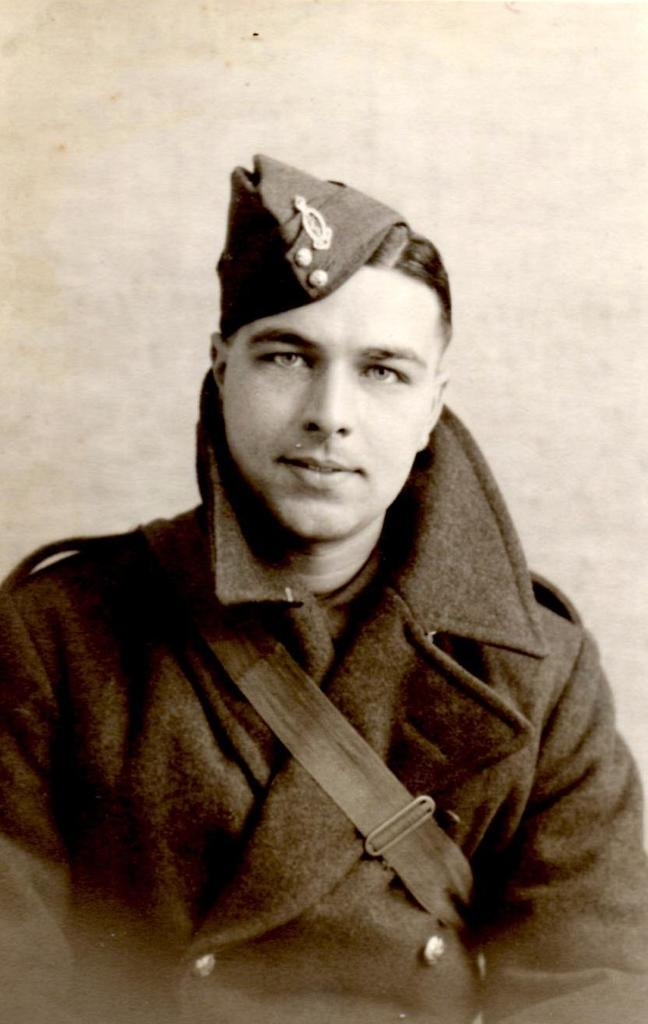What is the main subject of the image? The main subject of the image is a person. What can be seen on the person's head? The person is wearing a cap. What is the person wearing in the image? The person is wearing clothes. What color is the background of the image? The background of the image is white. What type of discovery was made by the dolls in the image? There are no dolls present in the image, so no discovery can be made by them. 